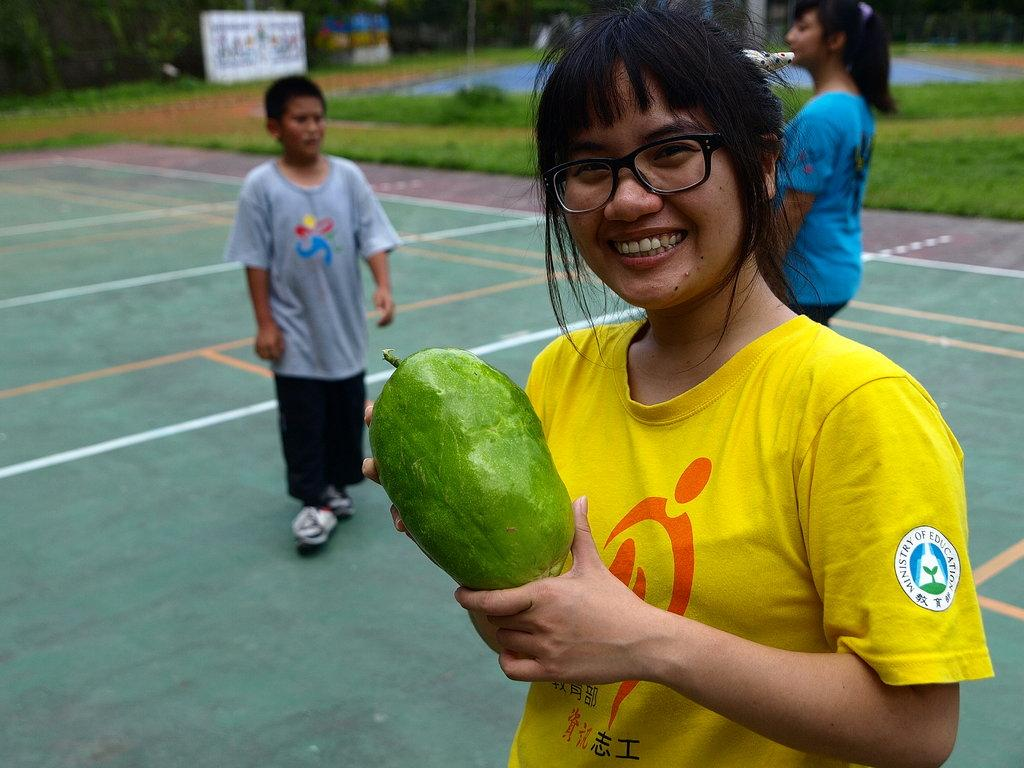What is the woman on the right side of the image holding? The woman is holding a fruit in her hands. Can you describe the people in the background of the image? There is a boy and another woman in the background of the image. What is the position of the boy and the woman in the background? The boy and the woman are standing on the ground. What type of barrier can be seen in the image? There is a fence visible in the image. What else can be seen in the background of the image? There are hoardings in the background of the image. What type of vegetation is present in the image? Grass is present in the image. What type of committee is meeting in the alley in the image? There is no committee meeting in the image, nor is there an alley present. 